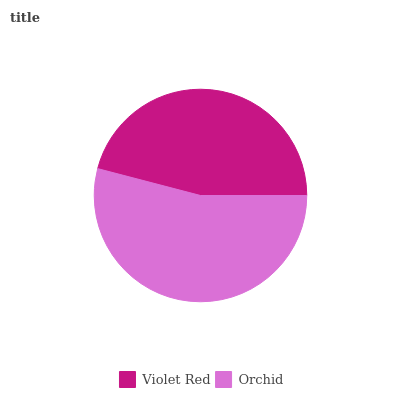Is Violet Red the minimum?
Answer yes or no. Yes. Is Orchid the maximum?
Answer yes or no. Yes. Is Orchid the minimum?
Answer yes or no. No. Is Orchid greater than Violet Red?
Answer yes or no. Yes. Is Violet Red less than Orchid?
Answer yes or no. Yes. Is Violet Red greater than Orchid?
Answer yes or no. No. Is Orchid less than Violet Red?
Answer yes or no. No. Is Orchid the high median?
Answer yes or no. Yes. Is Violet Red the low median?
Answer yes or no. Yes. Is Violet Red the high median?
Answer yes or no. No. Is Orchid the low median?
Answer yes or no. No. 